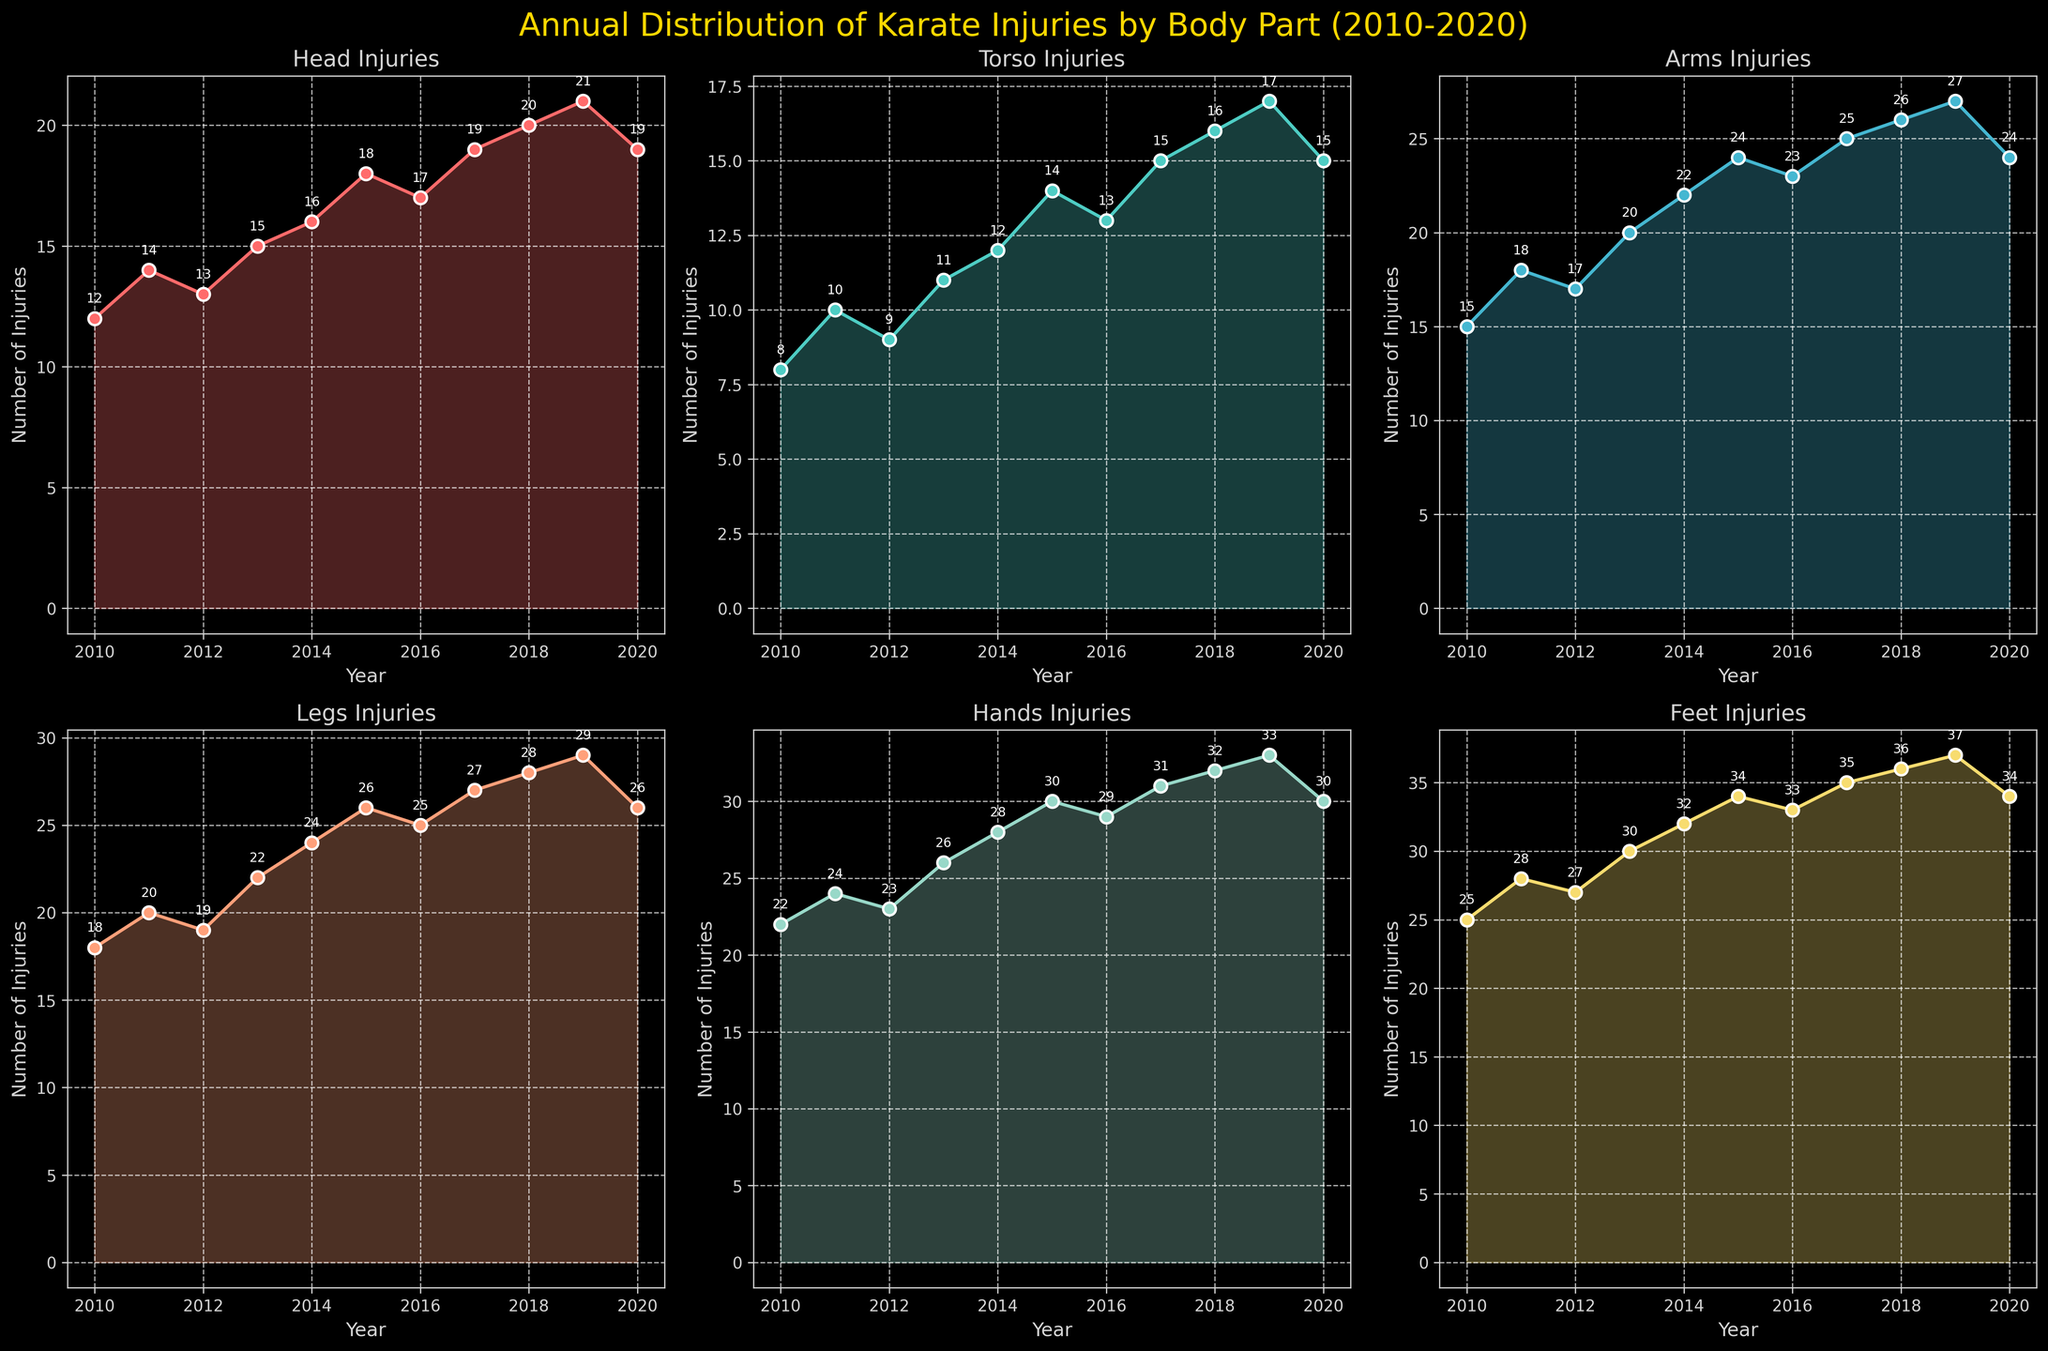Which body part had the highest number of injuries in 2020? Look at the figure for the 2020 data points across all subplots. The subplot for Feet shows the highest point.
Answer: Feet Which body part had the lowest number of injuries in 2014? Look at the figure for the 2014 data points across all subplots. The subplot for Torso shows the lowest point.
Answer: Torso In which year did hand injuries equal 28? Check the subplot for Hands and find the data point marked as 28. The corresponding year is 2011.
Answer: 2011 By how many points did head injuries increase from 2010 to 2014? In the subplot for Head injuries, locate the data points for 2010 and 2014. Subtract the 2010 value from the 2014 value: 16 - 12 = 4.
Answer: 4 What is the total number of injuries across all body parts in 2018? Sum the data points for each body part in 2018: 20 (Head) + 16 (Torso) + 26 (Arms) + 28 (Legs) + 32 (Hands) + 36 (Feet). The total is 158.
Answer: 158 Which body part saw the most consistent increase in injuries over the years? Compare the slope and pattern of each line across all subplots. The subplot for Feet shows a very consistent increase.
Answer: Feet What is the largest year-to-year increase in any body part's injuries, and which body part does it correspond to? Examine each subplot for the largest vertical change between consecutive years. The largest increase is in Hands from 2013 to 2014, which is 4 (24 to 28).
Answer: Hands, 4 Which body part experienced a decrease in injuries from 2019 to 2020? Check each subplot for a downward slope from 2019 to 2020. Both Head and Torso show a decrease.
Answer: Head, Torso How many more injuries were reported for legs than for torsos in 2016? Look at the subplots for Legs and Torso and subtract the 2016 values for each: 25 (Legs) - 13 (Torso) = 12.
Answer: 12 What is the average number of foot injuries reported per year between 2010 and 2020? Sum the foot injuries from 2010 to 2020 and divide by the number of years: (25 + 28 + 27 + 30 + 32 + 34 + 33 + 35 + 36 + 37 + 34)/11 = 32.
Answer: 32 